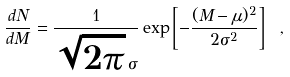Convert formula to latex. <formula><loc_0><loc_0><loc_500><loc_500>\frac { d N } { d M } = \frac { 1 } { \sqrt { 2 \pi } \, \sigma } \exp \left [ - \frac { ( M - \mu ) ^ { 2 } } { 2 \sigma ^ { 2 } } \right ] \ ,</formula> 